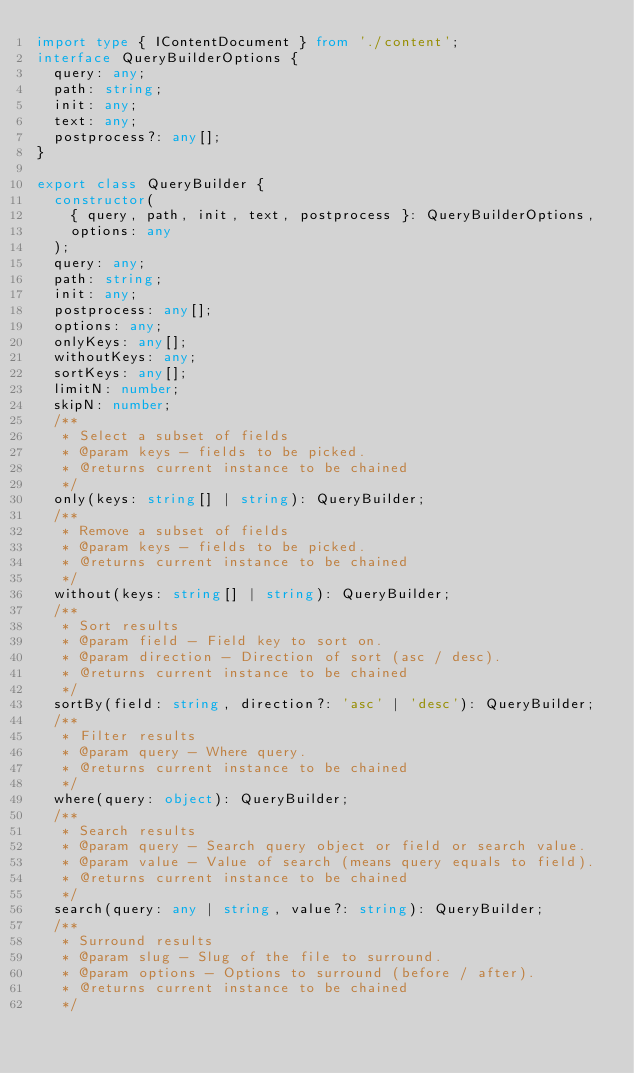<code> <loc_0><loc_0><loc_500><loc_500><_TypeScript_>import type { IContentDocument } from './content';
interface QueryBuilderOptions {
  query: any;
  path: string;
  init: any;
  text: any;
  postprocess?: any[];
}

export class QueryBuilder {
  constructor(
    { query, path, init, text, postprocess }: QueryBuilderOptions,
    options: any
  );
  query: any;
  path: string;
  init: any;
  postprocess: any[];
  options: any;
  onlyKeys: any[];
  withoutKeys: any;
  sortKeys: any[];
  limitN: number;
  skipN: number;
  /**
   * Select a subset of fields
   * @param keys - fields to be picked.
   * @returns current instance to be chained
   */
  only(keys: string[] | string): QueryBuilder;
  /**
   * Remove a subset of fields
   * @param keys - fields to be picked.
   * @returns current instance to be chained
   */
  without(keys: string[] | string): QueryBuilder;
  /**
   * Sort results
   * @param field - Field key to sort on.
   * @param direction - Direction of sort (asc / desc).
   * @returns current instance to be chained
   */
  sortBy(field: string, direction?: 'asc' | 'desc'): QueryBuilder;
  /**
   * Filter results
   * @param query - Where query.
   * @returns current instance to be chained
   */
  where(query: object): QueryBuilder;
  /**
   * Search results
   * @param query - Search query object or field or search value.
   * @param value - Value of search (means query equals to field).
   * @returns current instance to be chained
   */
  search(query: any | string, value?: string): QueryBuilder;
  /**
   * Surround results
   * @param slug - Slug of the file to surround.
   * @param options - Options to surround (before / after).
   * @returns current instance to be chained
   */</code> 